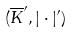<formula> <loc_0><loc_0><loc_500><loc_500>( \overline { K } ^ { \prime } , | \cdot | ^ { \prime } )</formula> 